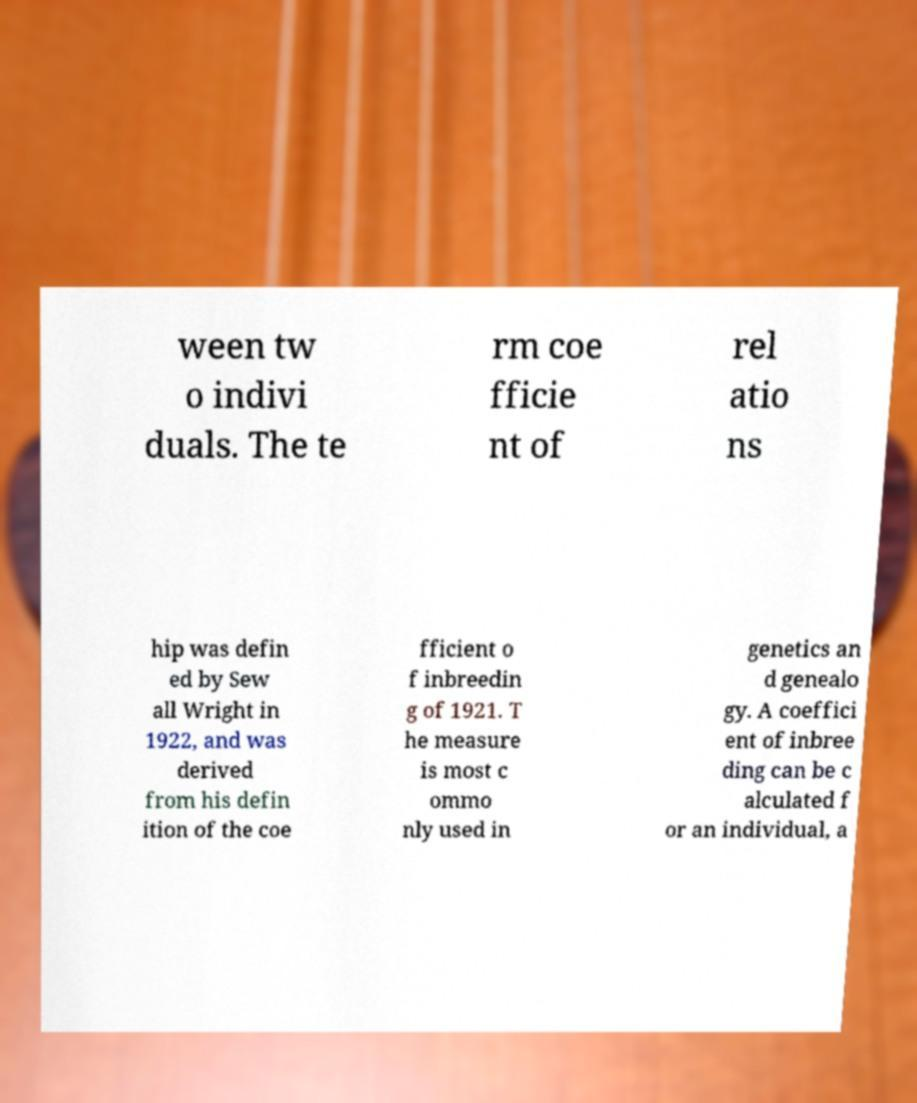Could you extract and type out the text from this image? ween tw o indivi duals. The te rm coe fficie nt of rel atio ns hip was defin ed by Sew all Wright in 1922, and was derived from his defin ition of the coe fficient o f inbreedin g of 1921. T he measure is most c ommo nly used in genetics an d genealo gy. A coeffici ent of inbree ding can be c alculated f or an individual, a 